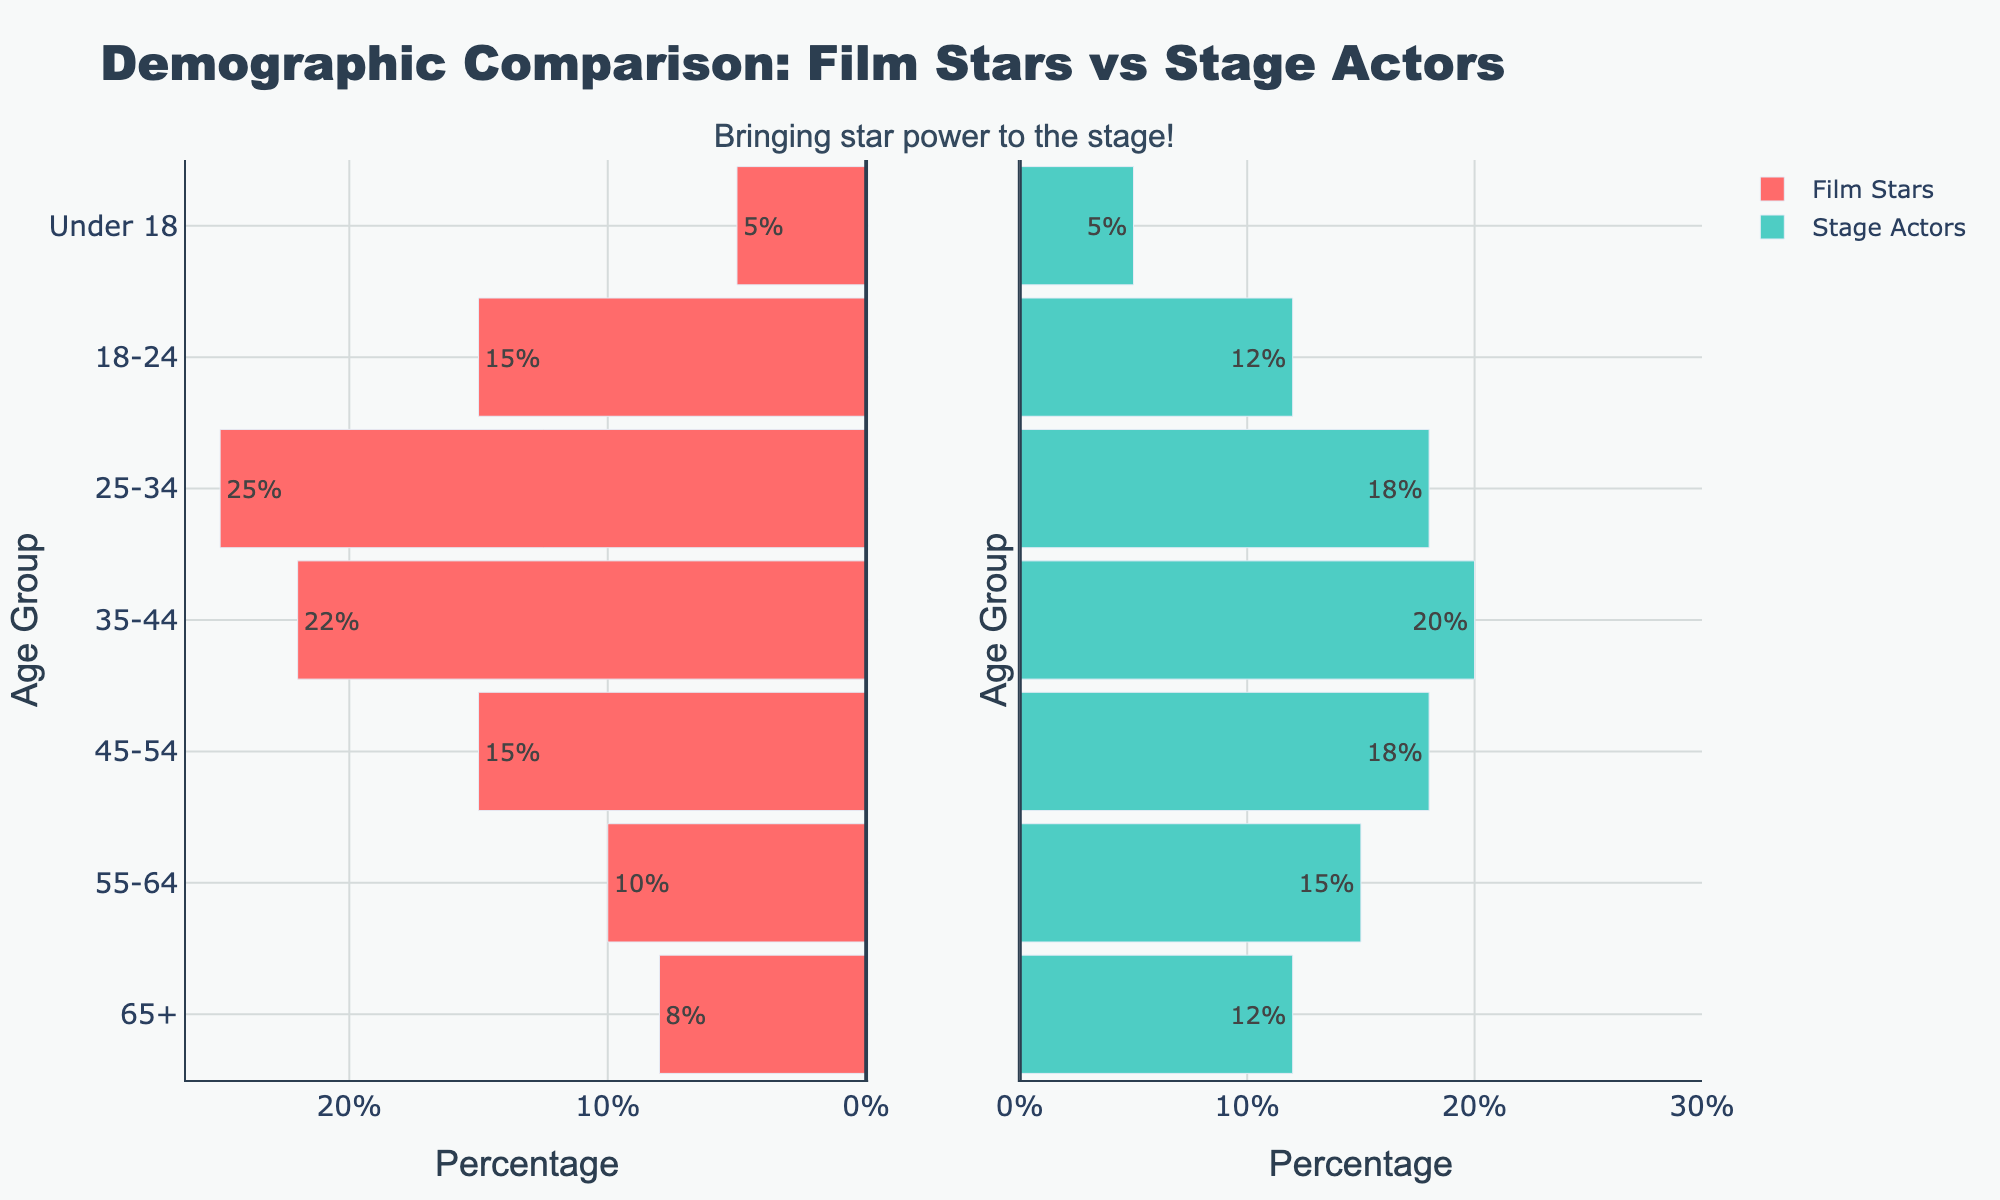What's the title of the figure? The title is located at the top of the figure and provides a summary of what the plot represents.
Answer: Demographic Comparison: Film Stars vs Stage Actors What's the subtitle of the figure? The subtitle is placed beneath the main title and gives additional context or a message related to the data.
Answer: Bringing star power to the stage! Which age group has the highest percentage of attendees for film stars? Check the bar lengths for film stars on the plot; the longest bar represents the highest percentage.
Answer: 25-34 Describe the color scheme used for the bars representing film stars and stage actors. The colors are used to differentiate between the two categories; each category has a unique color as shown in the legend.
Answer: Film stars: red, Stage actors: green In which age groups do stage actors have a higher percentage than film stars? Compare the bar lengths in each age group to see where stage actors' bars are longer than film stars' bars.
Answer: 65+, 55-64, 45-54 What is the total percentage of attendees under 18 for both groups combined? Add the percentages of film stars and stage actors for the 'Under 18' age group.
Answer: 10% Which age group shows the biggest difference in percentage between film stars and stage actors? Calculate the absolute difference for each age group, then identify the largest difference.
Answer: 25-34 What is the percentage difference between film stars and stage actors in the 55-64 age group? Subtract the smaller percentage from the larger one for the 55-64 age group.
Answer: 5% How do the percentages for 18-24 compare between film stars and stage actors? Look at the lengths of the bars corresponding to the 18-24 age group for both categories.
Answer: Film stars: higher by 3% What's the trend in attendee percentages from younger to older age groups for film stars? Observing the plot, note how the bar lengths change from younger to older age groups.
Answer: Decreases 